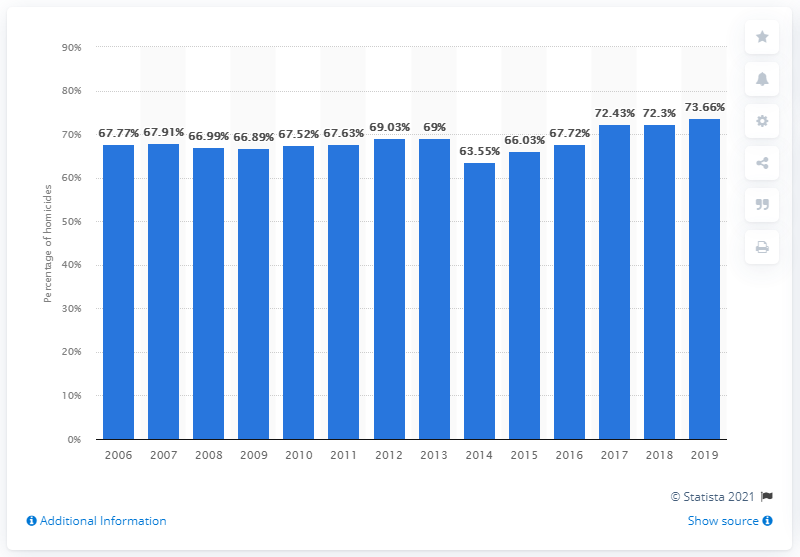Identify some key points in this picture. Since 2017, the percentage of homicides committed by firearms has increased. 